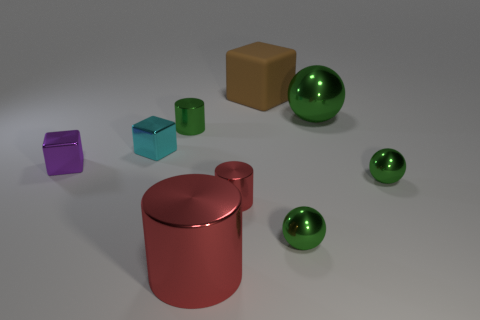What number of metallic objects are either big red cubes or small cyan blocks?
Give a very brief answer. 1. What number of big green balls are behind the large metal ball right of the purple object?
Provide a short and direct response. 0. There is a metallic cylinder that is the same color as the big ball; what is its size?
Make the answer very short. Small. How many objects are big brown rubber cubes or tiny green cylinders that are on the left side of the brown rubber object?
Make the answer very short. 2. Are there any tiny purple spheres that have the same material as the big brown block?
Make the answer very short. No. What number of tiny green objects are right of the brown thing and to the left of the large red cylinder?
Your answer should be compact. 0. What material is the big thing that is right of the brown matte cube?
Your answer should be very brief. Metal. There is a purple cube that is the same material as the big green ball; what size is it?
Offer a terse response. Small. Are there any objects behind the green metallic cylinder?
Your response must be concise. Yes. There is a cyan thing that is the same shape as the purple metal object; what size is it?
Offer a very short reply. Small. 